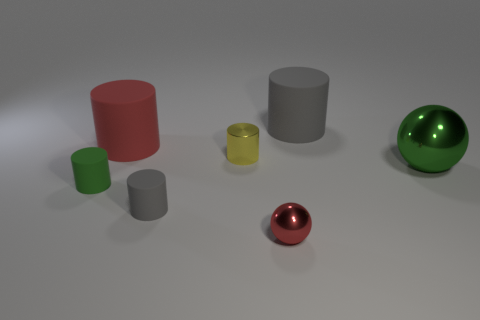Does the rubber thing on the left side of the large red cylinder have the same color as the large metal object?
Ensure brevity in your answer.  Yes. Is there a rubber cylinder of the same color as the tiny sphere?
Your answer should be compact. Yes. What number of red objects are the same material as the green ball?
Ensure brevity in your answer.  1. Are there the same number of small metallic balls on the left side of the tiny green rubber thing and large objects that are in front of the tiny yellow shiny thing?
Give a very brief answer. No. Do the big gray thing and the green thing left of the big gray cylinder have the same shape?
Keep it short and to the point. Yes. There is a object that is the same color as the small metal sphere; what is its material?
Ensure brevity in your answer.  Rubber. Is there any other thing that is the same shape as the yellow thing?
Keep it short and to the point. Yes. Do the yellow cylinder and the green object to the right of the red shiny ball have the same material?
Provide a short and direct response. Yes. What is the color of the cylinder that is right of the metal cylinder that is on the left side of the red thing that is in front of the large red cylinder?
Your answer should be very brief. Gray. Are there any other things that are the same size as the yellow object?
Your answer should be very brief. Yes. 